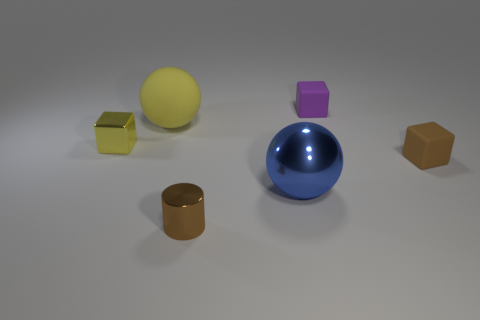Is the number of tiny cyan rubber cylinders greater than the number of small purple matte blocks?
Provide a succinct answer. No. What is the material of the big yellow ball?
Make the answer very short. Rubber. What is the color of the big sphere that is left of the large metal thing?
Your answer should be very brief. Yellow. Is the number of big metallic objects that are on the left side of the yellow matte object greater than the number of small matte objects in front of the big metallic object?
Provide a short and direct response. No. There is a brown object on the left side of the small rubber cube behind the yellow object that is in front of the yellow rubber sphere; how big is it?
Give a very brief answer. Small. Is there a small cylinder that has the same color as the tiny metal cube?
Provide a succinct answer. No. How many green rubber things are there?
Your answer should be very brief. 0. What is the material of the brown thing on the right side of the tiny brown object left of the tiny block in front of the small metallic block?
Your answer should be compact. Rubber. Are there any cyan balls that have the same material as the large yellow ball?
Offer a very short reply. No. Are the tiny purple thing and the small cylinder made of the same material?
Provide a succinct answer. No. 